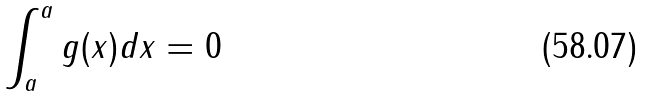Convert formula to latex. <formula><loc_0><loc_0><loc_500><loc_500>\int _ { a } ^ { a } g ( x ) d x = 0</formula> 